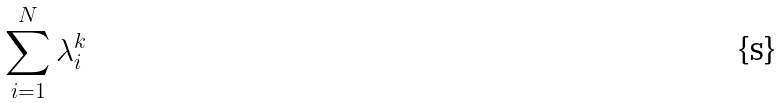<formula> <loc_0><loc_0><loc_500><loc_500>\sum _ { i = 1 } ^ { N } \lambda _ { i } ^ { k }</formula> 